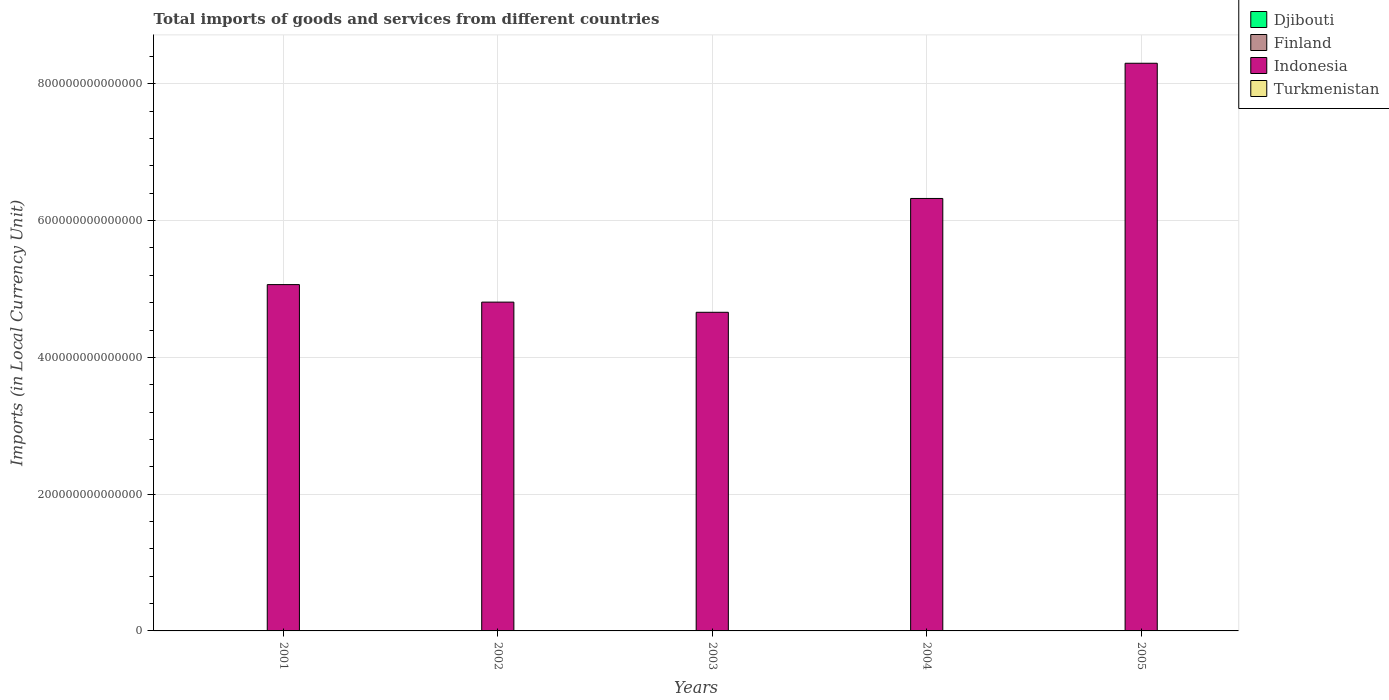Are the number of bars per tick equal to the number of legend labels?
Offer a terse response. Yes. Are the number of bars on each tick of the X-axis equal?
Give a very brief answer. Yes. How many bars are there on the 4th tick from the right?
Make the answer very short. 4. What is the label of the 1st group of bars from the left?
Provide a succinct answer. 2001. In how many cases, is the number of bars for a given year not equal to the number of legend labels?
Offer a very short reply. 0. What is the Amount of goods and services imports in Indonesia in 2002?
Provide a succinct answer. 4.81e+14. Across all years, what is the maximum Amount of goods and services imports in Turkmenistan?
Make the answer very short. 8.79e+09. Across all years, what is the minimum Amount of goods and services imports in Turkmenistan?
Provide a short and direct response. 4.83e+09. In which year was the Amount of goods and services imports in Djibouti maximum?
Your answer should be very brief. 2005. In which year was the Amount of goods and services imports in Turkmenistan minimum?
Your answer should be compact. 2002. What is the total Amount of goods and services imports in Turkmenistan in the graph?
Provide a succinct answer. 3.44e+1. What is the difference between the Amount of goods and services imports in Finland in 2001 and that in 2005?
Your answer should be compact. -1.57e+1. What is the difference between the Amount of goods and services imports in Finland in 2001 and the Amount of goods and services imports in Turkmenistan in 2002?
Ensure brevity in your answer.  3.93e+1. What is the average Amount of goods and services imports in Djibouti per year?
Ensure brevity in your answer.  5.50e+1. In the year 2002, what is the difference between the Amount of goods and services imports in Turkmenistan and Amount of goods and services imports in Djibouti?
Your response must be concise. -4.11e+1. In how many years, is the Amount of goods and services imports in Finland greater than 400000000000000 LCU?
Your response must be concise. 0. What is the ratio of the Amount of goods and services imports in Djibouti in 2001 to that in 2004?
Your response must be concise. 0.73. Is the Amount of goods and services imports in Djibouti in 2002 less than that in 2004?
Offer a very short reply. Yes. What is the difference between the highest and the second highest Amount of goods and services imports in Turkmenistan?
Give a very brief answer. 2.55e+08. What is the difference between the highest and the lowest Amount of goods and services imports in Finland?
Keep it short and to the point. 1.57e+1. In how many years, is the Amount of goods and services imports in Finland greater than the average Amount of goods and services imports in Finland taken over all years?
Give a very brief answer. 2. Is the sum of the Amount of goods and services imports in Djibouti in 2002 and 2005 greater than the maximum Amount of goods and services imports in Finland across all years?
Ensure brevity in your answer.  Yes. What does the 1st bar from the left in 2002 represents?
Give a very brief answer. Djibouti. Is it the case that in every year, the sum of the Amount of goods and services imports in Finland and Amount of goods and services imports in Turkmenistan is greater than the Amount of goods and services imports in Djibouti?
Offer a very short reply. No. What is the difference between two consecutive major ticks on the Y-axis?
Provide a short and direct response. 2.00e+14. Are the values on the major ticks of Y-axis written in scientific E-notation?
Ensure brevity in your answer.  No. Does the graph contain any zero values?
Offer a terse response. No. How many legend labels are there?
Your response must be concise. 4. How are the legend labels stacked?
Offer a terse response. Vertical. What is the title of the graph?
Your answer should be very brief. Total imports of goods and services from different countries. What is the label or title of the X-axis?
Your response must be concise. Years. What is the label or title of the Y-axis?
Ensure brevity in your answer.  Imports (in Local Currency Unit). What is the Imports (in Local Currency Unit) in Djibouti in 2001?
Provide a succinct answer. 4.66e+1. What is the Imports (in Local Currency Unit) of Finland in 2001?
Give a very brief answer. 4.41e+1. What is the Imports (in Local Currency Unit) of Indonesia in 2001?
Keep it short and to the point. 5.06e+14. What is the Imports (in Local Currency Unit) in Turkmenistan in 2001?
Keep it short and to the point. 5.54e+09. What is the Imports (in Local Currency Unit) of Djibouti in 2002?
Offer a terse response. 4.60e+1. What is the Imports (in Local Currency Unit) in Finland in 2002?
Your answer should be very brief. 4.48e+1. What is the Imports (in Local Currency Unit) in Indonesia in 2002?
Provide a succinct answer. 4.81e+14. What is the Imports (in Local Currency Unit) in Turkmenistan in 2002?
Provide a succinct answer. 4.83e+09. What is the Imports (in Local Currency Unit) of Djibouti in 2003?
Offer a very short reply. 5.42e+1. What is the Imports (in Local Currency Unit) of Finland in 2003?
Your answer should be compact. 4.66e+1. What is the Imports (in Local Currency Unit) of Indonesia in 2003?
Your answer should be compact. 4.66e+14. What is the Imports (in Local Currency Unit) of Turkmenistan in 2003?
Your answer should be very brief. 6.73e+09. What is the Imports (in Local Currency Unit) in Djibouti in 2004?
Offer a very short reply. 6.41e+1. What is the Imports (in Local Currency Unit) in Finland in 2004?
Offer a very short reply. 5.14e+1. What is the Imports (in Local Currency Unit) in Indonesia in 2004?
Give a very brief answer. 6.32e+14. What is the Imports (in Local Currency Unit) in Turkmenistan in 2004?
Your answer should be very brief. 8.79e+09. What is the Imports (in Local Currency Unit) in Djibouti in 2005?
Your answer should be compact. 6.42e+1. What is the Imports (in Local Currency Unit) in Finland in 2005?
Your answer should be very brief. 5.98e+1. What is the Imports (in Local Currency Unit) of Indonesia in 2005?
Keep it short and to the point. 8.30e+14. What is the Imports (in Local Currency Unit) in Turkmenistan in 2005?
Give a very brief answer. 8.53e+09. Across all years, what is the maximum Imports (in Local Currency Unit) of Djibouti?
Your answer should be very brief. 6.42e+1. Across all years, what is the maximum Imports (in Local Currency Unit) in Finland?
Your answer should be compact. 5.98e+1. Across all years, what is the maximum Imports (in Local Currency Unit) of Indonesia?
Keep it short and to the point. 8.30e+14. Across all years, what is the maximum Imports (in Local Currency Unit) in Turkmenistan?
Provide a short and direct response. 8.79e+09. Across all years, what is the minimum Imports (in Local Currency Unit) of Djibouti?
Your answer should be very brief. 4.60e+1. Across all years, what is the minimum Imports (in Local Currency Unit) of Finland?
Make the answer very short. 4.41e+1. Across all years, what is the minimum Imports (in Local Currency Unit) of Indonesia?
Give a very brief answer. 4.66e+14. Across all years, what is the minimum Imports (in Local Currency Unit) in Turkmenistan?
Provide a succinct answer. 4.83e+09. What is the total Imports (in Local Currency Unit) of Djibouti in the graph?
Offer a very short reply. 2.75e+11. What is the total Imports (in Local Currency Unit) in Finland in the graph?
Your answer should be very brief. 2.47e+11. What is the total Imports (in Local Currency Unit) in Indonesia in the graph?
Keep it short and to the point. 2.92e+15. What is the total Imports (in Local Currency Unit) of Turkmenistan in the graph?
Give a very brief answer. 3.44e+1. What is the difference between the Imports (in Local Currency Unit) in Djibouti in 2001 and that in 2002?
Provide a short and direct response. 6.03e+08. What is the difference between the Imports (in Local Currency Unit) of Finland in 2001 and that in 2002?
Offer a terse response. -6.60e+08. What is the difference between the Imports (in Local Currency Unit) in Indonesia in 2001 and that in 2002?
Offer a very short reply. 2.56e+13. What is the difference between the Imports (in Local Currency Unit) of Turkmenistan in 2001 and that in 2002?
Offer a very short reply. 7.11e+08. What is the difference between the Imports (in Local Currency Unit) of Djibouti in 2001 and that in 2003?
Offer a terse response. -7.68e+09. What is the difference between the Imports (in Local Currency Unit) of Finland in 2001 and that in 2003?
Offer a very short reply. -2.51e+09. What is the difference between the Imports (in Local Currency Unit) in Indonesia in 2001 and that in 2003?
Give a very brief answer. 4.05e+13. What is the difference between the Imports (in Local Currency Unit) of Turkmenistan in 2001 and that in 2003?
Offer a terse response. -1.18e+09. What is the difference between the Imports (in Local Currency Unit) in Djibouti in 2001 and that in 2004?
Your answer should be compact. -1.76e+1. What is the difference between the Imports (in Local Currency Unit) in Finland in 2001 and that in 2004?
Ensure brevity in your answer.  -7.22e+09. What is the difference between the Imports (in Local Currency Unit) in Indonesia in 2001 and that in 2004?
Ensure brevity in your answer.  -1.26e+14. What is the difference between the Imports (in Local Currency Unit) of Turkmenistan in 2001 and that in 2004?
Offer a terse response. -3.25e+09. What is the difference between the Imports (in Local Currency Unit) of Djibouti in 2001 and that in 2005?
Keep it short and to the point. -1.76e+1. What is the difference between the Imports (in Local Currency Unit) in Finland in 2001 and that in 2005?
Ensure brevity in your answer.  -1.57e+1. What is the difference between the Imports (in Local Currency Unit) of Indonesia in 2001 and that in 2005?
Your answer should be compact. -3.24e+14. What is the difference between the Imports (in Local Currency Unit) of Turkmenistan in 2001 and that in 2005?
Offer a very short reply. -2.99e+09. What is the difference between the Imports (in Local Currency Unit) in Djibouti in 2002 and that in 2003?
Offer a very short reply. -8.29e+09. What is the difference between the Imports (in Local Currency Unit) in Finland in 2002 and that in 2003?
Offer a very short reply. -1.85e+09. What is the difference between the Imports (in Local Currency Unit) of Indonesia in 2002 and that in 2003?
Provide a short and direct response. 1.49e+13. What is the difference between the Imports (in Local Currency Unit) of Turkmenistan in 2002 and that in 2003?
Give a very brief answer. -1.89e+09. What is the difference between the Imports (in Local Currency Unit) in Djibouti in 2002 and that in 2004?
Your response must be concise. -1.82e+1. What is the difference between the Imports (in Local Currency Unit) of Finland in 2002 and that in 2004?
Your answer should be compact. -6.56e+09. What is the difference between the Imports (in Local Currency Unit) in Indonesia in 2002 and that in 2004?
Your answer should be very brief. -1.52e+14. What is the difference between the Imports (in Local Currency Unit) in Turkmenistan in 2002 and that in 2004?
Make the answer very short. -3.96e+09. What is the difference between the Imports (in Local Currency Unit) of Djibouti in 2002 and that in 2005?
Your answer should be very brief. -1.82e+1. What is the difference between the Imports (in Local Currency Unit) of Finland in 2002 and that in 2005?
Your answer should be very brief. -1.50e+1. What is the difference between the Imports (in Local Currency Unit) of Indonesia in 2002 and that in 2005?
Your response must be concise. -3.49e+14. What is the difference between the Imports (in Local Currency Unit) of Turkmenistan in 2002 and that in 2005?
Give a very brief answer. -3.70e+09. What is the difference between the Imports (in Local Currency Unit) in Djibouti in 2003 and that in 2004?
Your response must be concise. -9.88e+09. What is the difference between the Imports (in Local Currency Unit) of Finland in 2003 and that in 2004?
Your answer should be very brief. -4.71e+09. What is the difference between the Imports (in Local Currency Unit) in Indonesia in 2003 and that in 2004?
Your answer should be very brief. -1.66e+14. What is the difference between the Imports (in Local Currency Unit) of Turkmenistan in 2003 and that in 2004?
Keep it short and to the point. -2.06e+09. What is the difference between the Imports (in Local Currency Unit) of Djibouti in 2003 and that in 2005?
Provide a succinct answer. -9.93e+09. What is the difference between the Imports (in Local Currency Unit) of Finland in 2003 and that in 2005?
Give a very brief answer. -1.32e+1. What is the difference between the Imports (in Local Currency Unit) in Indonesia in 2003 and that in 2005?
Make the answer very short. -3.64e+14. What is the difference between the Imports (in Local Currency Unit) of Turkmenistan in 2003 and that in 2005?
Offer a terse response. -1.81e+09. What is the difference between the Imports (in Local Currency Unit) in Djibouti in 2004 and that in 2005?
Offer a terse response. -5.33e+07. What is the difference between the Imports (in Local Currency Unit) of Finland in 2004 and that in 2005?
Keep it short and to the point. -8.44e+09. What is the difference between the Imports (in Local Currency Unit) of Indonesia in 2004 and that in 2005?
Give a very brief answer. -1.98e+14. What is the difference between the Imports (in Local Currency Unit) in Turkmenistan in 2004 and that in 2005?
Your answer should be compact. 2.55e+08. What is the difference between the Imports (in Local Currency Unit) of Djibouti in 2001 and the Imports (in Local Currency Unit) of Finland in 2002?
Your answer should be compact. 1.77e+09. What is the difference between the Imports (in Local Currency Unit) in Djibouti in 2001 and the Imports (in Local Currency Unit) in Indonesia in 2002?
Provide a succinct answer. -4.81e+14. What is the difference between the Imports (in Local Currency Unit) of Djibouti in 2001 and the Imports (in Local Currency Unit) of Turkmenistan in 2002?
Provide a succinct answer. 4.17e+1. What is the difference between the Imports (in Local Currency Unit) of Finland in 2001 and the Imports (in Local Currency Unit) of Indonesia in 2002?
Provide a succinct answer. -4.81e+14. What is the difference between the Imports (in Local Currency Unit) in Finland in 2001 and the Imports (in Local Currency Unit) in Turkmenistan in 2002?
Ensure brevity in your answer.  3.93e+1. What is the difference between the Imports (in Local Currency Unit) of Indonesia in 2001 and the Imports (in Local Currency Unit) of Turkmenistan in 2002?
Provide a short and direct response. 5.06e+14. What is the difference between the Imports (in Local Currency Unit) of Djibouti in 2001 and the Imports (in Local Currency Unit) of Finland in 2003?
Your answer should be compact. -7.60e+07. What is the difference between the Imports (in Local Currency Unit) of Djibouti in 2001 and the Imports (in Local Currency Unit) of Indonesia in 2003?
Give a very brief answer. -4.66e+14. What is the difference between the Imports (in Local Currency Unit) of Djibouti in 2001 and the Imports (in Local Currency Unit) of Turkmenistan in 2003?
Offer a terse response. 3.98e+1. What is the difference between the Imports (in Local Currency Unit) in Finland in 2001 and the Imports (in Local Currency Unit) in Indonesia in 2003?
Your response must be concise. -4.66e+14. What is the difference between the Imports (in Local Currency Unit) of Finland in 2001 and the Imports (in Local Currency Unit) of Turkmenistan in 2003?
Your answer should be compact. 3.74e+1. What is the difference between the Imports (in Local Currency Unit) in Indonesia in 2001 and the Imports (in Local Currency Unit) in Turkmenistan in 2003?
Provide a short and direct response. 5.06e+14. What is the difference between the Imports (in Local Currency Unit) of Djibouti in 2001 and the Imports (in Local Currency Unit) of Finland in 2004?
Your answer should be compact. -4.79e+09. What is the difference between the Imports (in Local Currency Unit) of Djibouti in 2001 and the Imports (in Local Currency Unit) of Indonesia in 2004?
Your response must be concise. -6.32e+14. What is the difference between the Imports (in Local Currency Unit) of Djibouti in 2001 and the Imports (in Local Currency Unit) of Turkmenistan in 2004?
Provide a succinct answer. 3.78e+1. What is the difference between the Imports (in Local Currency Unit) in Finland in 2001 and the Imports (in Local Currency Unit) in Indonesia in 2004?
Provide a short and direct response. -6.32e+14. What is the difference between the Imports (in Local Currency Unit) in Finland in 2001 and the Imports (in Local Currency Unit) in Turkmenistan in 2004?
Offer a very short reply. 3.53e+1. What is the difference between the Imports (in Local Currency Unit) in Indonesia in 2001 and the Imports (in Local Currency Unit) in Turkmenistan in 2004?
Provide a short and direct response. 5.06e+14. What is the difference between the Imports (in Local Currency Unit) in Djibouti in 2001 and the Imports (in Local Currency Unit) in Finland in 2005?
Make the answer very short. -1.32e+1. What is the difference between the Imports (in Local Currency Unit) in Djibouti in 2001 and the Imports (in Local Currency Unit) in Indonesia in 2005?
Your answer should be very brief. -8.30e+14. What is the difference between the Imports (in Local Currency Unit) in Djibouti in 2001 and the Imports (in Local Currency Unit) in Turkmenistan in 2005?
Make the answer very short. 3.80e+1. What is the difference between the Imports (in Local Currency Unit) in Finland in 2001 and the Imports (in Local Currency Unit) in Indonesia in 2005?
Provide a succinct answer. -8.30e+14. What is the difference between the Imports (in Local Currency Unit) in Finland in 2001 and the Imports (in Local Currency Unit) in Turkmenistan in 2005?
Keep it short and to the point. 3.56e+1. What is the difference between the Imports (in Local Currency Unit) in Indonesia in 2001 and the Imports (in Local Currency Unit) in Turkmenistan in 2005?
Offer a terse response. 5.06e+14. What is the difference between the Imports (in Local Currency Unit) of Djibouti in 2002 and the Imports (in Local Currency Unit) of Finland in 2003?
Your answer should be very brief. -6.79e+08. What is the difference between the Imports (in Local Currency Unit) of Djibouti in 2002 and the Imports (in Local Currency Unit) of Indonesia in 2003?
Make the answer very short. -4.66e+14. What is the difference between the Imports (in Local Currency Unit) of Djibouti in 2002 and the Imports (in Local Currency Unit) of Turkmenistan in 2003?
Make the answer very short. 3.92e+1. What is the difference between the Imports (in Local Currency Unit) in Finland in 2002 and the Imports (in Local Currency Unit) in Indonesia in 2003?
Offer a terse response. -4.66e+14. What is the difference between the Imports (in Local Currency Unit) of Finland in 2002 and the Imports (in Local Currency Unit) of Turkmenistan in 2003?
Provide a succinct answer. 3.81e+1. What is the difference between the Imports (in Local Currency Unit) of Indonesia in 2002 and the Imports (in Local Currency Unit) of Turkmenistan in 2003?
Offer a very short reply. 4.81e+14. What is the difference between the Imports (in Local Currency Unit) in Djibouti in 2002 and the Imports (in Local Currency Unit) in Finland in 2004?
Make the answer very short. -5.39e+09. What is the difference between the Imports (in Local Currency Unit) in Djibouti in 2002 and the Imports (in Local Currency Unit) in Indonesia in 2004?
Your answer should be very brief. -6.32e+14. What is the difference between the Imports (in Local Currency Unit) in Djibouti in 2002 and the Imports (in Local Currency Unit) in Turkmenistan in 2004?
Your response must be concise. 3.72e+1. What is the difference between the Imports (in Local Currency Unit) in Finland in 2002 and the Imports (in Local Currency Unit) in Indonesia in 2004?
Your answer should be very brief. -6.32e+14. What is the difference between the Imports (in Local Currency Unit) of Finland in 2002 and the Imports (in Local Currency Unit) of Turkmenistan in 2004?
Make the answer very short. 3.60e+1. What is the difference between the Imports (in Local Currency Unit) in Indonesia in 2002 and the Imports (in Local Currency Unit) in Turkmenistan in 2004?
Give a very brief answer. 4.81e+14. What is the difference between the Imports (in Local Currency Unit) of Djibouti in 2002 and the Imports (in Local Currency Unit) of Finland in 2005?
Ensure brevity in your answer.  -1.38e+1. What is the difference between the Imports (in Local Currency Unit) of Djibouti in 2002 and the Imports (in Local Currency Unit) of Indonesia in 2005?
Provide a short and direct response. -8.30e+14. What is the difference between the Imports (in Local Currency Unit) of Djibouti in 2002 and the Imports (in Local Currency Unit) of Turkmenistan in 2005?
Offer a terse response. 3.74e+1. What is the difference between the Imports (in Local Currency Unit) in Finland in 2002 and the Imports (in Local Currency Unit) in Indonesia in 2005?
Make the answer very short. -8.30e+14. What is the difference between the Imports (in Local Currency Unit) in Finland in 2002 and the Imports (in Local Currency Unit) in Turkmenistan in 2005?
Offer a very short reply. 3.63e+1. What is the difference between the Imports (in Local Currency Unit) in Indonesia in 2002 and the Imports (in Local Currency Unit) in Turkmenistan in 2005?
Provide a succinct answer. 4.81e+14. What is the difference between the Imports (in Local Currency Unit) in Djibouti in 2003 and the Imports (in Local Currency Unit) in Finland in 2004?
Ensure brevity in your answer.  2.90e+09. What is the difference between the Imports (in Local Currency Unit) in Djibouti in 2003 and the Imports (in Local Currency Unit) in Indonesia in 2004?
Your answer should be very brief. -6.32e+14. What is the difference between the Imports (in Local Currency Unit) of Djibouti in 2003 and the Imports (in Local Currency Unit) of Turkmenistan in 2004?
Offer a very short reply. 4.55e+1. What is the difference between the Imports (in Local Currency Unit) of Finland in 2003 and the Imports (in Local Currency Unit) of Indonesia in 2004?
Offer a very short reply. -6.32e+14. What is the difference between the Imports (in Local Currency Unit) in Finland in 2003 and the Imports (in Local Currency Unit) in Turkmenistan in 2004?
Ensure brevity in your answer.  3.79e+1. What is the difference between the Imports (in Local Currency Unit) in Indonesia in 2003 and the Imports (in Local Currency Unit) in Turkmenistan in 2004?
Offer a terse response. 4.66e+14. What is the difference between the Imports (in Local Currency Unit) of Djibouti in 2003 and the Imports (in Local Currency Unit) of Finland in 2005?
Your response must be concise. -5.54e+09. What is the difference between the Imports (in Local Currency Unit) of Djibouti in 2003 and the Imports (in Local Currency Unit) of Indonesia in 2005?
Provide a succinct answer. -8.30e+14. What is the difference between the Imports (in Local Currency Unit) of Djibouti in 2003 and the Imports (in Local Currency Unit) of Turkmenistan in 2005?
Your answer should be compact. 4.57e+1. What is the difference between the Imports (in Local Currency Unit) of Finland in 2003 and the Imports (in Local Currency Unit) of Indonesia in 2005?
Ensure brevity in your answer.  -8.30e+14. What is the difference between the Imports (in Local Currency Unit) in Finland in 2003 and the Imports (in Local Currency Unit) in Turkmenistan in 2005?
Provide a succinct answer. 3.81e+1. What is the difference between the Imports (in Local Currency Unit) of Indonesia in 2003 and the Imports (in Local Currency Unit) of Turkmenistan in 2005?
Your response must be concise. 4.66e+14. What is the difference between the Imports (in Local Currency Unit) of Djibouti in 2004 and the Imports (in Local Currency Unit) of Finland in 2005?
Keep it short and to the point. 4.33e+09. What is the difference between the Imports (in Local Currency Unit) in Djibouti in 2004 and the Imports (in Local Currency Unit) in Indonesia in 2005?
Provide a short and direct response. -8.30e+14. What is the difference between the Imports (in Local Currency Unit) in Djibouti in 2004 and the Imports (in Local Currency Unit) in Turkmenistan in 2005?
Make the answer very short. 5.56e+1. What is the difference between the Imports (in Local Currency Unit) of Finland in 2004 and the Imports (in Local Currency Unit) of Indonesia in 2005?
Your answer should be compact. -8.30e+14. What is the difference between the Imports (in Local Currency Unit) in Finland in 2004 and the Imports (in Local Currency Unit) in Turkmenistan in 2005?
Ensure brevity in your answer.  4.28e+1. What is the difference between the Imports (in Local Currency Unit) in Indonesia in 2004 and the Imports (in Local Currency Unit) in Turkmenistan in 2005?
Offer a very short reply. 6.32e+14. What is the average Imports (in Local Currency Unit) of Djibouti per year?
Offer a very short reply. 5.50e+1. What is the average Imports (in Local Currency Unit) of Finland per year?
Make the answer very short. 4.93e+1. What is the average Imports (in Local Currency Unit) of Indonesia per year?
Give a very brief answer. 5.83e+14. What is the average Imports (in Local Currency Unit) of Turkmenistan per year?
Your answer should be very brief. 6.88e+09. In the year 2001, what is the difference between the Imports (in Local Currency Unit) of Djibouti and Imports (in Local Currency Unit) of Finland?
Provide a succinct answer. 2.43e+09. In the year 2001, what is the difference between the Imports (in Local Currency Unit) of Djibouti and Imports (in Local Currency Unit) of Indonesia?
Provide a succinct answer. -5.06e+14. In the year 2001, what is the difference between the Imports (in Local Currency Unit) in Djibouti and Imports (in Local Currency Unit) in Turkmenistan?
Your answer should be compact. 4.10e+1. In the year 2001, what is the difference between the Imports (in Local Currency Unit) of Finland and Imports (in Local Currency Unit) of Indonesia?
Keep it short and to the point. -5.06e+14. In the year 2001, what is the difference between the Imports (in Local Currency Unit) of Finland and Imports (in Local Currency Unit) of Turkmenistan?
Provide a short and direct response. 3.86e+1. In the year 2001, what is the difference between the Imports (in Local Currency Unit) in Indonesia and Imports (in Local Currency Unit) in Turkmenistan?
Give a very brief answer. 5.06e+14. In the year 2002, what is the difference between the Imports (in Local Currency Unit) of Djibouti and Imports (in Local Currency Unit) of Finland?
Keep it short and to the point. 1.17e+09. In the year 2002, what is the difference between the Imports (in Local Currency Unit) of Djibouti and Imports (in Local Currency Unit) of Indonesia?
Your answer should be very brief. -4.81e+14. In the year 2002, what is the difference between the Imports (in Local Currency Unit) in Djibouti and Imports (in Local Currency Unit) in Turkmenistan?
Ensure brevity in your answer.  4.11e+1. In the year 2002, what is the difference between the Imports (in Local Currency Unit) of Finland and Imports (in Local Currency Unit) of Indonesia?
Ensure brevity in your answer.  -4.81e+14. In the year 2002, what is the difference between the Imports (in Local Currency Unit) in Finland and Imports (in Local Currency Unit) in Turkmenistan?
Your answer should be very brief. 4.00e+1. In the year 2002, what is the difference between the Imports (in Local Currency Unit) in Indonesia and Imports (in Local Currency Unit) in Turkmenistan?
Your answer should be very brief. 4.81e+14. In the year 2003, what is the difference between the Imports (in Local Currency Unit) in Djibouti and Imports (in Local Currency Unit) in Finland?
Ensure brevity in your answer.  7.61e+09. In the year 2003, what is the difference between the Imports (in Local Currency Unit) of Djibouti and Imports (in Local Currency Unit) of Indonesia?
Offer a very short reply. -4.66e+14. In the year 2003, what is the difference between the Imports (in Local Currency Unit) in Djibouti and Imports (in Local Currency Unit) in Turkmenistan?
Your answer should be compact. 4.75e+1. In the year 2003, what is the difference between the Imports (in Local Currency Unit) of Finland and Imports (in Local Currency Unit) of Indonesia?
Offer a very short reply. -4.66e+14. In the year 2003, what is the difference between the Imports (in Local Currency Unit) of Finland and Imports (in Local Currency Unit) of Turkmenistan?
Provide a short and direct response. 3.99e+1. In the year 2003, what is the difference between the Imports (in Local Currency Unit) of Indonesia and Imports (in Local Currency Unit) of Turkmenistan?
Provide a succinct answer. 4.66e+14. In the year 2004, what is the difference between the Imports (in Local Currency Unit) in Djibouti and Imports (in Local Currency Unit) in Finland?
Provide a short and direct response. 1.28e+1. In the year 2004, what is the difference between the Imports (in Local Currency Unit) in Djibouti and Imports (in Local Currency Unit) in Indonesia?
Offer a very short reply. -6.32e+14. In the year 2004, what is the difference between the Imports (in Local Currency Unit) of Djibouti and Imports (in Local Currency Unit) of Turkmenistan?
Provide a short and direct response. 5.53e+1. In the year 2004, what is the difference between the Imports (in Local Currency Unit) in Finland and Imports (in Local Currency Unit) in Indonesia?
Make the answer very short. -6.32e+14. In the year 2004, what is the difference between the Imports (in Local Currency Unit) in Finland and Imports (in Local Currency Unit) in Turkmenistan?
Your response must be concise. 4.26e+1. In the year 2004, what is the difference between the Imports (in Local Currency Unit) in Indonesia and Imports (in Local Currency Unit) in Turkmenistan?
Make the answer very short. 6.32e+14. In the year 2005, what is the difference between the Imports (in Local Currency Unit) in Djibouti and Imports (in Local Currency Unit) in Finland?
Your answer should be very brief. 4.38e+09. In the year 2005, what is the difference between the Imports (in Local Currency Unit) in Djibouti and Imports (in Local Currency Unit) in Indonesia?
Make the answer very short. -8.30e+14. In the year 2005, what is the difference between the Imports (in Local Currency Unit) of Djibouti and Imports (in Local Currency Unit) of Turkmenistan?
Offer a terse response. 5.56e+1. In the year 2005, what is the difference between the Imports (in Local Currency Unit) in Finland and Imports (in Local Currency Unit) in Indonesia?
Your answer should be compact. -8.30e+14. In the year 2005, what is the difference between the Imports (in Local Currency Unit) in Finland and Imports (in Local Currency Unit) in Turkmenistan?
Your response must be concise. 5.13e+1. In the year 2005, what is the difference between the Imports (in Local Currency Unit) of Indonesia and Imports (in Local Currency Unit) of Turkmenistan?
Your answer should be compact. 8.30e+14. What is the ratio of the Imports (in Local Currency Unit) of Djibouti in 2001 to that in 2002?
Your answer should be very brief. 1.01. What is the ratio of the Imports (in Local Currency Unit) of Finland in 2001 to that in 2002?
Give a very brief answer. 0.99. What is the ratio of the Imports (in Local Currency Unit) in Indonesia in 2001 to that in 2002?
Offer a terse response. 1.05. What is the ratio of the Imports (in Local Currency Unit) in Turkmenistan in 2001 to that in 2002?
Ensure brevity in your answer.  1.15. What is the ratio of the Imports (in Local Currency Unit) of Djibouti in 2001 to that in 2003?
Provide a succinct answer. 0.86. What is the ratio of the Imports (in Local Currency Unit) in Finland in 2001 to that in 2003?
Offer a very short reply. 0.95. What is the ratio of the Imports (in Local Currency Unit) of Indonesia in 2001 to that in 2003?
Provide a short and direct response. 1.09. What is the ratio of the Imports (in Local Currency Unit) in Turkmenistan in 2001 to that in 2003?
Keep it short and to the point. 0.82. What is the ratio of the Imports (in Local Currency Unit) in Djibouti in 2001 to that in 2004?
Your response must be concise. 0.73. What is the ratio of the Imports (in Local Currency Unit) in Finland in 2001 to that in 2004?
Your response must be concise. 0.86. What is the ratio of the Imports (in Local Currency Unit) in Indonesia in 2001 to that in 2004?
Provide a succinct answer. 0.8. What is the ratio of the Imports (in Local Currency Unit) in Turkmenistan in 2001 to that in 2004?
Your answer should be compact. 0.63. What is the ratio of the Imports (in Local Currency Unit) of Djibouti in 2001 to that in 2005?
Give a very brief answer. 0.73. What is the ratio of the Imports (in Local Currency Unit) in Finland in 2001 to that in 2005?
Make the answer very short. 0.74. What is the ratio of the Imports (in Local Currency Unit) in Indonesia in 2001 to that in 2005?
Give a very brief answer. 0.61. What is the ratio of the Imports (in Local Currency Unit) of Turkmenistan in 2001 to that in 2005?
Provide a short and direct response. 0.65. What is the ratio of the Imports (in Local Currency Unit) of Djibouti in 2002 to that in 2003?
Make the answer very short. 0.85. What is the ratio of the Imports (in Local Currency Unit) in Finland in 2002 to that in 2003?
Offer a terse response. 0.96. What is the ratio of the Imports (in Local Currency Unit) of Indonesia in 2002 to that in 2003?
Your answer should be compact. 1.03. What is the ratio of the Imports (in Local Currency Unit) of Turkmenistan in 2002 to that in 2003?
Keep it short and to the point. 0.72. What is the ratio of the Imports (in Local Currency Unit) of Djibouti in 2002 to that in 2004?
Keep it short and to the point. 0.72. What is the ratio of the Imports (in Local Currency Unit) in Finland in 2002 to that in 2004?
Provide a succinct answer. 0.87. What is the ratio of the Imports (in Local Currency Unit) of Indonesia in 2002 to that in 2004?
Provide a succinct answer. 0.76. What is the ratio of the Imports (in Local Currency Unit) of Turkmenistan in 2002 to that in 2004?
Keep it short and to the point. 0.55. What is the ratio of the Imports (in Local Currency Unit) of Djibouti in 2002 to that in 2005?
Your answer should be very brief. 0.72. What is the ratio of the Imports (in Local Currency Unit) of Finland in 2002 to that in 2005?
Provide a short and direct response. 0.75. What is the ratio of the Imports (in Local Currency Unit) of Indonesia in 2002 to that in 2005?
Offer a terse response. 0.58. What is the ratio of the Imports (in Local Currency Unit) of Turkmenistan in 2002 to that in 2005?
Offer a terse response. 0.57. What is the ratio of the Imports (in Local Currency Unit) of Djibouti in 2003 to that in 2004?
Provide a succinct answer. 0.85. What is the ratio of the Imports (in Local Currency Unit) in Finland in 2003 to that in 2004?
Provide a short and direct response. 0.91. What is the ratio of the Imports (in Local Currency Unit) in Indonesia in 2003 to that in 2004?
Your response must be concise. 0.74. What is the ratio of the Imports (in Local Currency Unit) in Turkmenistan in 2003 to that in 2004?
Provide a short and direct response. 0.77. What is the ratio of the Imports (in Local Currency Unit) of Djibouti in 2003 to that in 2005?
Provide a short and direct response. 0.85. What is the ratio of the Imports (in Local Currency Unit) in Finland in 2003 to that in 2005?
Ensure brevity in your answer.  0.78. What is the ratio of the Imports (in Local Currency Unit) in Indonesia in 2003 to that in 2005?
Your answer should be compact. 0.56. What is the ratio of the Imports (in Local Currency Unit) in Turkmenistan in 2003 to that in 2005?
Provide a short and direct response. 0.79. What is the ratio of the Imports (in Local Currency Unit) in Djibouti in 2004 to that in 2005?
Your response must be concise. 1. What is the ratio of the Imports (in Local Currency Unit) of Finland in 2004 to that in 2005?
Provide a short and direct response. 0.86. What is the ratio of the Imports (in Local Currency Unit) of Indonesia in 2004 to that in 2005?
Ensure brevity in your answer.  0.76. What is the ratio of the Imports (in Local Currency Unit) in Turkmenistan in 2004 to that in 2005?
Your answer should be compact. 1.03. What is the difference between the highest and the second highest Imports (in Local Currency Unit) of Djibouti?
Provide a succinct answer. 5.33e+07. What is the difference between the highest and the second highest Imports (in Local Currency Unit) in Finland?
Give a very brief answer. 8.44e+09. What is the difference between the highest and the second highest Imports (in Local Currency Unit) of Indonesia?
Provide a succinct answer. 1.98e+14. What is the difference between the highest and the second highest Imports (in Local Currency Unit) in Turkmenistan?
Offer a very short reply. 2.55e+08. What is the difference between the highest and the lowest Imports (in Local Currency Unit) in Djibouti?
Provide a succinct answer. 1.82e+1. What is the difference between the highest and the lowest Imports (in Local Currency Unit) in Finland?
Your response must be concise. 1.57e+1. What is the difference between the highest and the lowest Imports (in Local Currency Unit) in Indonesia?
Offer a terse response. 3.64e+14. What is the difference between the highest and the lowest Imports (in Local Currency Unit) in Turkmenistan?
Offer a terse response. 3.96e+09. 